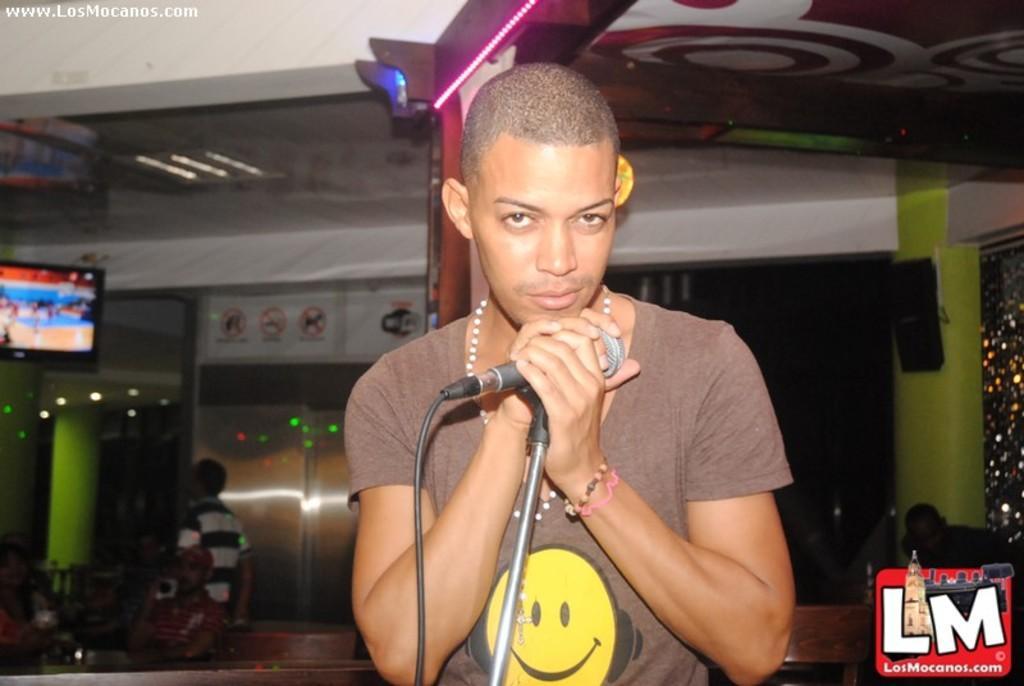How would you summarize this image in a sentence or two? In this image, in the middle there is a man, he wears a t shirt, he is holding a mic. At the bottom there is a text. In the background there are people, tv, lights, posters, roof, text. 